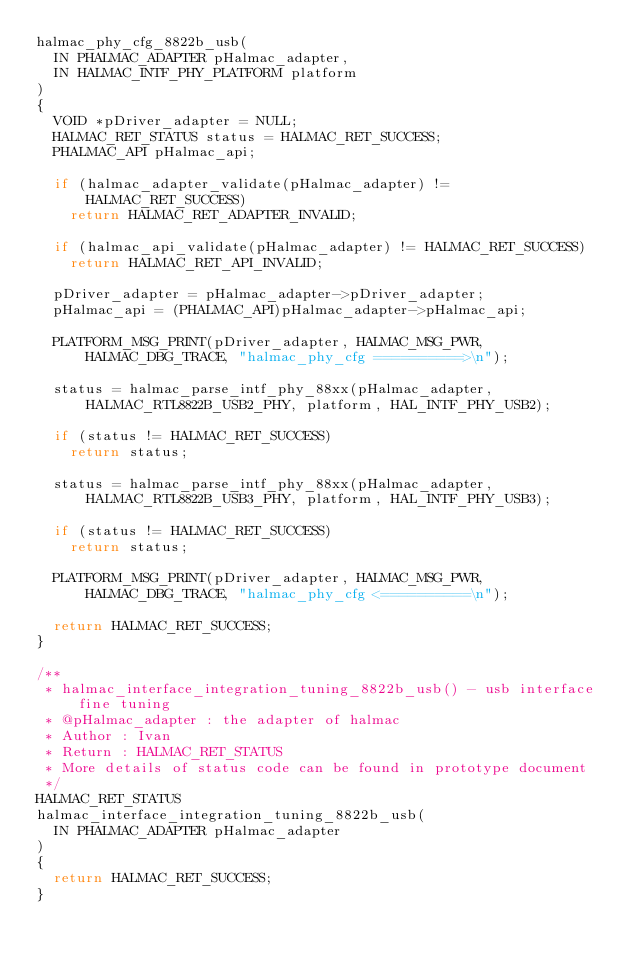Convert code to text. <code><loc_0><loc_0><loc_500><loc_500><_C_>halmac_phy_cfg_8822b_usb(
	IN PHALMAC_ADAPTER pHalmac_adapter,
	IN HALMAC_INTF_PHY_PLATFORM platform
)
{
	VOID *pDriver_adapter = NULL;
	HALMAC_RET_STATUS status = HALMAC_RET_SUCCESS;
	PHALMAC_API pHalmac_api;

	if (halmac_adapter_validate(pHalmac_adapter) != HALMAC_RET_SUCCESS)
		return HALMAC_RET_ADAPTER_INVALID;

	if (halmac_api_validate(pHalmac_adapter) != HALMAC_RET_SUCCESS)
		return HALMAC_RET_API_INVALID;

	pDriver_adapter = pHalmac_adapter->pDriver_adapter;
	pHalmac_api = (PHALMAC_API)pHalmac_adapter->pHalmac_api;

	PLATFORM_MSG_PRINT(pDriver_adapter, HALMAC_MSG_PWR, HALMAC_DBG_TRACE, "halmac_phy_cfg ==========>\n");

	status = halmac_parse_intf_phy_88xx(pHalmac_adapter, HALMAC_RTL8822B_USB2_PHY, platform, HAL_INTF_PHY_USB2);

	if (status != HALMAC_RET_SUCCESS)
		return status;

	status = halmac_parse_intf_phy_88xx(pHalmac_adapter, HALMAC_RTL8822B_USB3_PHY, platform, HAL_INTF_PHY_USB3);

	if (status != HALMAC_RET_SUCCESS)
		return status;

	PLATFORM_MSG_PRINT(pDriver_adapter, HALMAC_MSG_PWR, HALMAC_DBG_TRACE, "halmac_phy_cfg <==========\n");

	return HALMAC_RET_SUCCESS;
}

/**
 * halmac_interface_integration_tuning_8822b_usb() - usb interface fine tuning
 * @pHalmac_adapter : the adapter of halmac
 * Author : Ivan
 * Return : HALMAC_RET_STATUS
 * More details of status code can be found in prototype document
 */
HALMAC_RET_STATUS
halmac_interface_integration_tuning_8822b_usb(
	IN PHALMAC_ADAPTER pHalmac_adapter
)
{
	return HALMAC_RET_SUCCESS;
}
</code> 